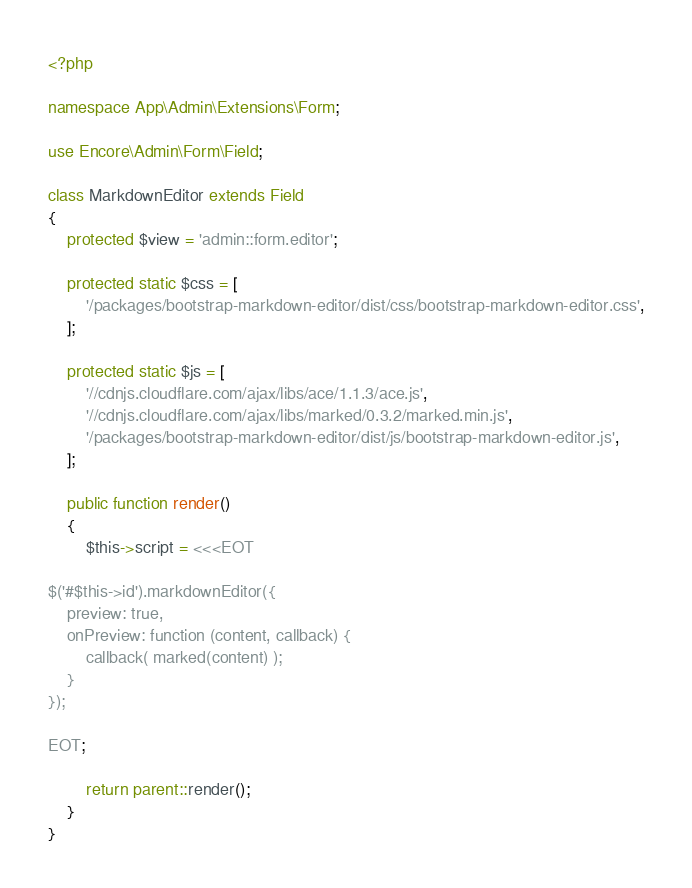Convert code to text. <code><loc_0><loc_0><loc_500><loc_500><_PHP_><?php

namespace App\Admin\Extensions\Form;

use Encore\Admin\Form\Field;

class MarkdownEditor extends Field
{
    protected $view = 'admin::form.editor';

    protected static $css = [
        '/packages/bootstrap-markdown-editor/dist/css/bootstrap-markdown-editor.css',
    ];

    protected static $js = [
        '//cdnjs.cloudflare.com/ajax/libs/ace/1.1.3/ace.js',
        '//cdnjs.cloudflare.com/ajax/libs/marked/0.3.2/marked.min.js',
        '/packages/bootstrap-markdown-editor/dist/js/bootstrap-markdown-editor.js',
    ];

    public function render()
    {
        $this->script = <<<EOT

$('#$this->id').markdownEditor({
    preview: true,
    onPreview: function (content, callback) {
        callback( marked(content) );
    }
});

EOT;

        return parent::render();
    }
}
</code> 